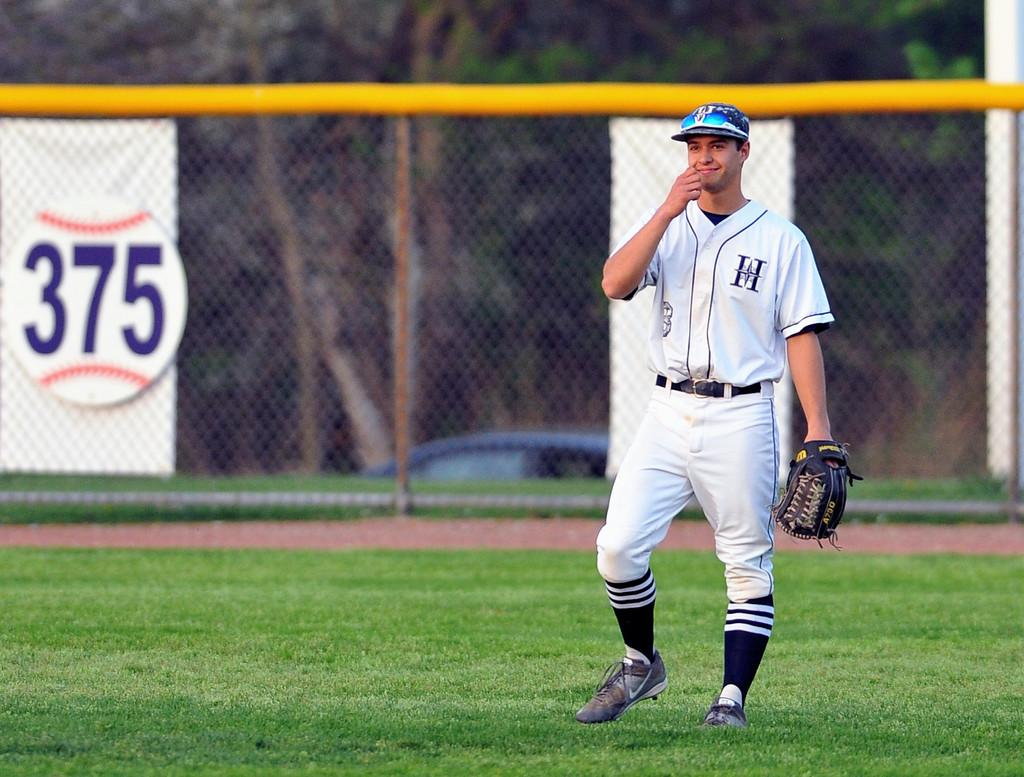<image>
Relay a brief, clear account of the picture shown. a person with a jersey on with the letter H 